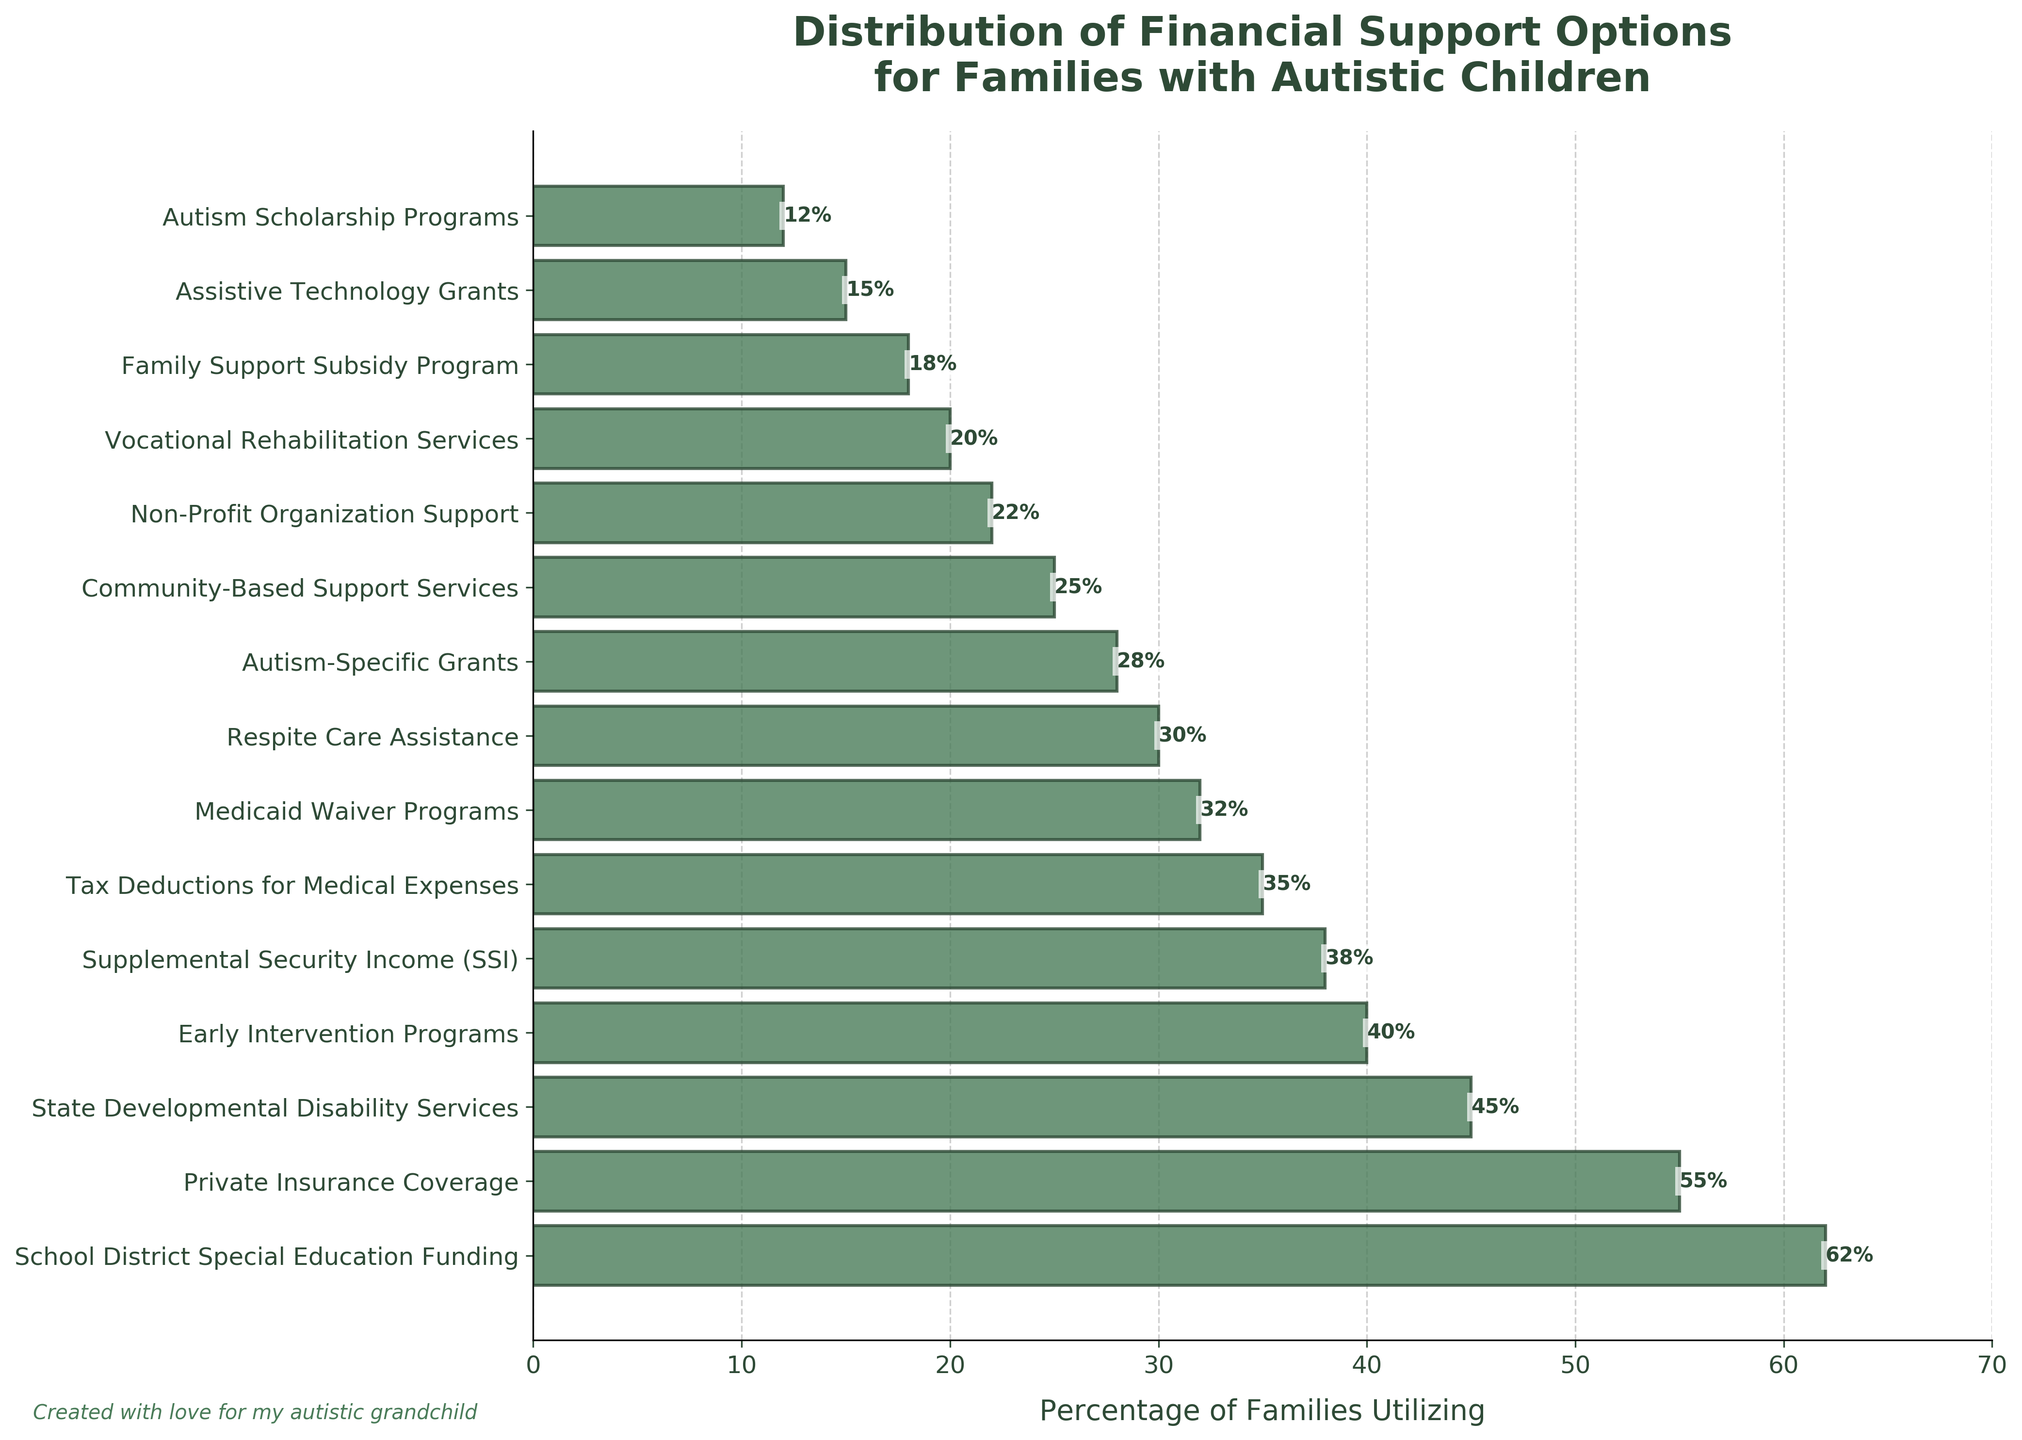Which financial support option is utilized by the highest percentage of families? By examining the horizontal bars, the bar for "School District Special Education Funding" is the longest, reaching the 62% mark, indicating it is the most utilized support option.
Answer: School District Special Education Funding Which financial support option is the least utilized? The shortest bar belongs to "Autism Scholarship Programs," indicating it has the smallest percentage of families utilizing it, which is 12%.
Answer: Autism Scholarship Programs How many financial support options are utilized by over 50% of families? By looking at the bars, "School District Special Education Funding" (62%) and "Private Insurance Coverage" (55%) are the only two options with bars extending beyond the 50% mark.
Answer: 2 What is the difference in the percentage of families utilizing State Developmental Disability Services and Medicaid Waiver Programs? The bar for State Developmental Disability Services shows 45%, and the bar for Medicaid Waiver Programs shows 32%. The difference is calculated as 45% - 32%.
Answer: 13% Which options are utilized by more families, Early Intervention Programs or Tax Deductions for Medical Expenses? Comparing the bars visually, the one for Early Intervention Programs is at 40%, while the bar for Tax Deductions for Medical Expenses is at 35%. Therefore, Early Intervention Programs are utilized by more families.
Answer: Early Intervention Programs What is the total percentage of families utilizing Supplemental Security Income (SSI) and Respite Care Assistance combined? The bar for Supplemental Security Income (SSI) is 38%, and the bar for Respite Care Assistance is 30%. Adding these two values together, we get 38% + 30%.
Answer: 68% Which support option's utilization is closest to 30%? By visually comparing the bars to the 30% mark, the bar for Respite Care Assistance is exactly at 30%.
Answer: Respite Care Assistance Does the percentage of families utilizing Non-Profit Organization Support exceed 20%? The bar for Non-Profit Organization Support is observed to reach the 22% mark, which is greater than 20%.
Answer: Yes What is the average percentage of utilization for State Developmental Disability Services, School District Special Education Funding, and Private Insurance Coverage? The percentages for these options are 45%, 62%, and 55%, respectively. Summing these gives 45% + 62% + 55% = 162%. Dividing by the 3 options, we get 162% / 3.
Answer: 54% Which has a higher utilization, Early Intervention Programs or Community-Based Support Services, and by how much? The bar for Early Intervention Programs reaches 40%, while the bar for Community-Based Support Services is at 25%. The difference is 40% - 25%.
Answer: Early Intervention Programs by 15% 